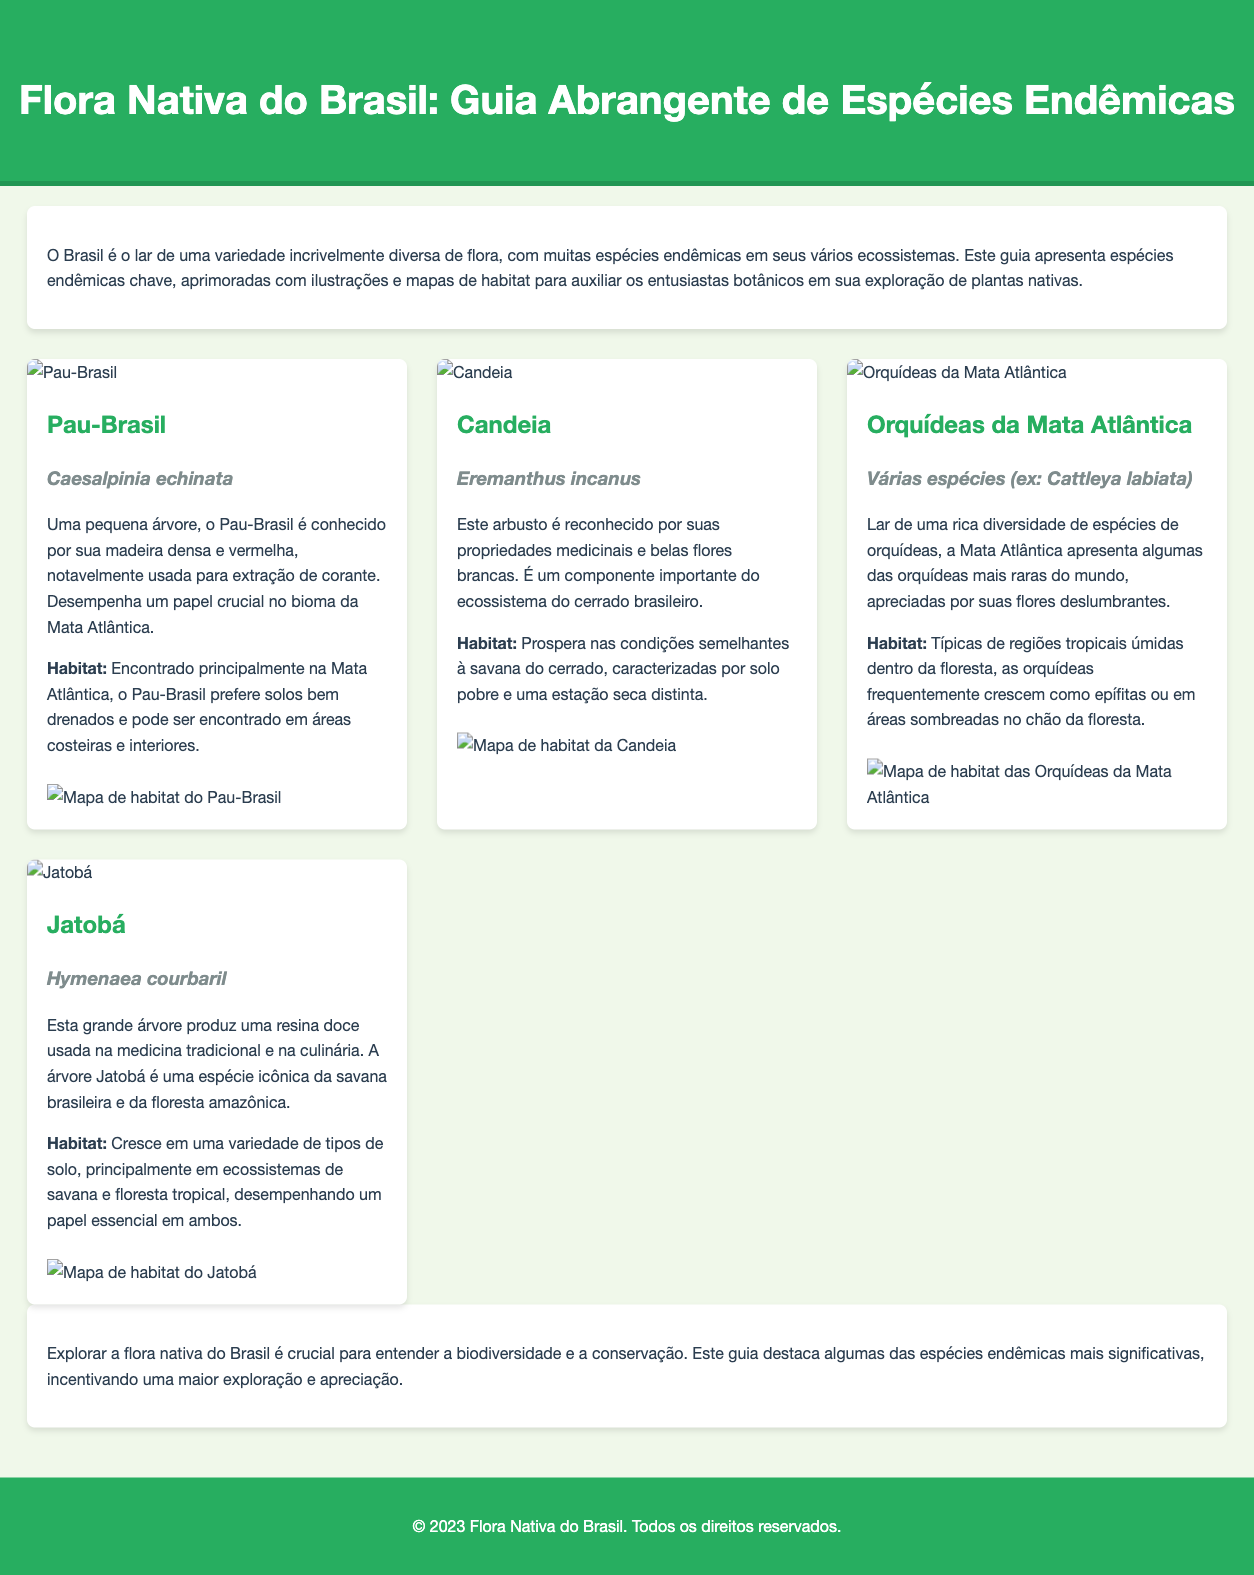Qual é o nome científico do Pau-Brasil? O nome científico do Pau-Brasil é uma informação específica apresentada na seção da planta.
Answer: Caesalpinia echinata Onde o Pau-Brasil é encontrado? A localização do Pau-Brasil é descrita na seção pertinente, especificamente mencionando tipos de habitat.
Answer: Mata Atlântica Qual planta é conhecida por suas propriedades medicinais e flores brancas? A descrição das plantas no documento permite identificar a planta com propriedades medicinais e flores brancas.
Answer: Candeia Quantas espécies de orquídeas da Mata Atlântica são mencionadas? O texto menciona que várias espécies estão presentes, mas cita especificamente uma espécie na seção.
Answer: Cattleya labiata Qual é o papel do Jatobá em seus ecossistemas? A descrição do Jatobá aborda sua importância em tipos de solo e ecossistemas específicos.
Answer: Essencial Qual é a principal característica do Jatobá? A característica principal do Jatobá é destacada na seção que descreve a planta e seu uso.
Answer: Produz resina doce Quantos tipos de solos a árvore Jatobá pode crescer? O texto menciona que a árvore Jatobá cresce em uma variedade de tipos de solo.
Answer: Vários Qual é a cor da madeira do Pau-Brasil? A informação sobre a cor da madeira do Pau-Brasil é mencionada em sua descrição.
Answer: Densa e vermelha Em que bioma o Pau-Brasil desempenha um papel crucial? A descrição do Pau-Brasil informa o bioma no qual ele é uma espécie significativa.
Answer: Mata Atlântica 